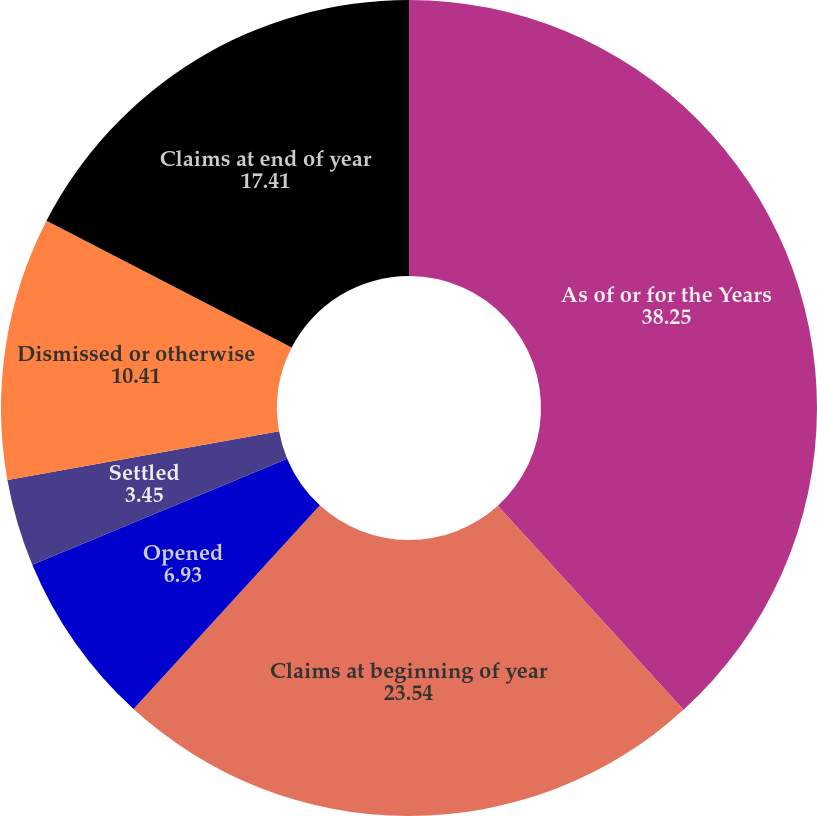Convert chart. <chart><loc_0><loc_0><loc_500><loc_500><pie_chart><fcel>As of or for the Years<fcel>Claims at beginning of year<fcel>Opened<fcel>Settled<fcel>Dismissed or otherwise<fcel>Claims at end of year<nl><fcel>38.25%<fcel>23.54%<fcel>6.93%<fcel>3.45%<fcel>10.41%<fcel>17.41%<nl></chart> 